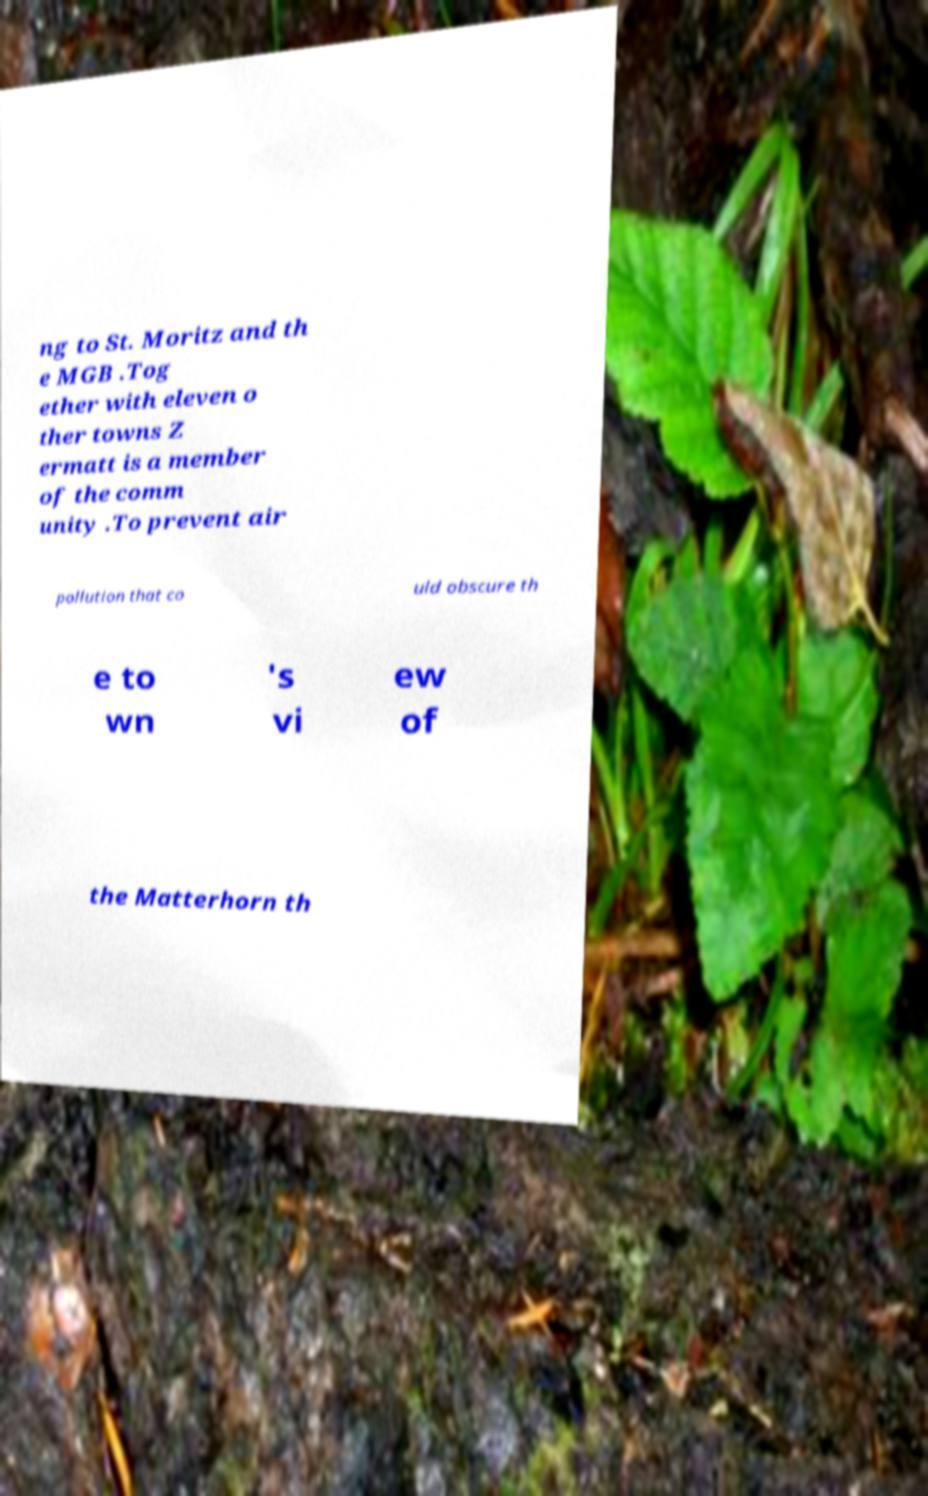Could you extract and type out the text from this image? ng to St. Moritz and th e MGB .Tog ether with eleven o ther towns Z ermatt is a member of the comm unity .To prevent air pollution that co uld obscure th e to wn 's vi ew of the Matterhorn th 